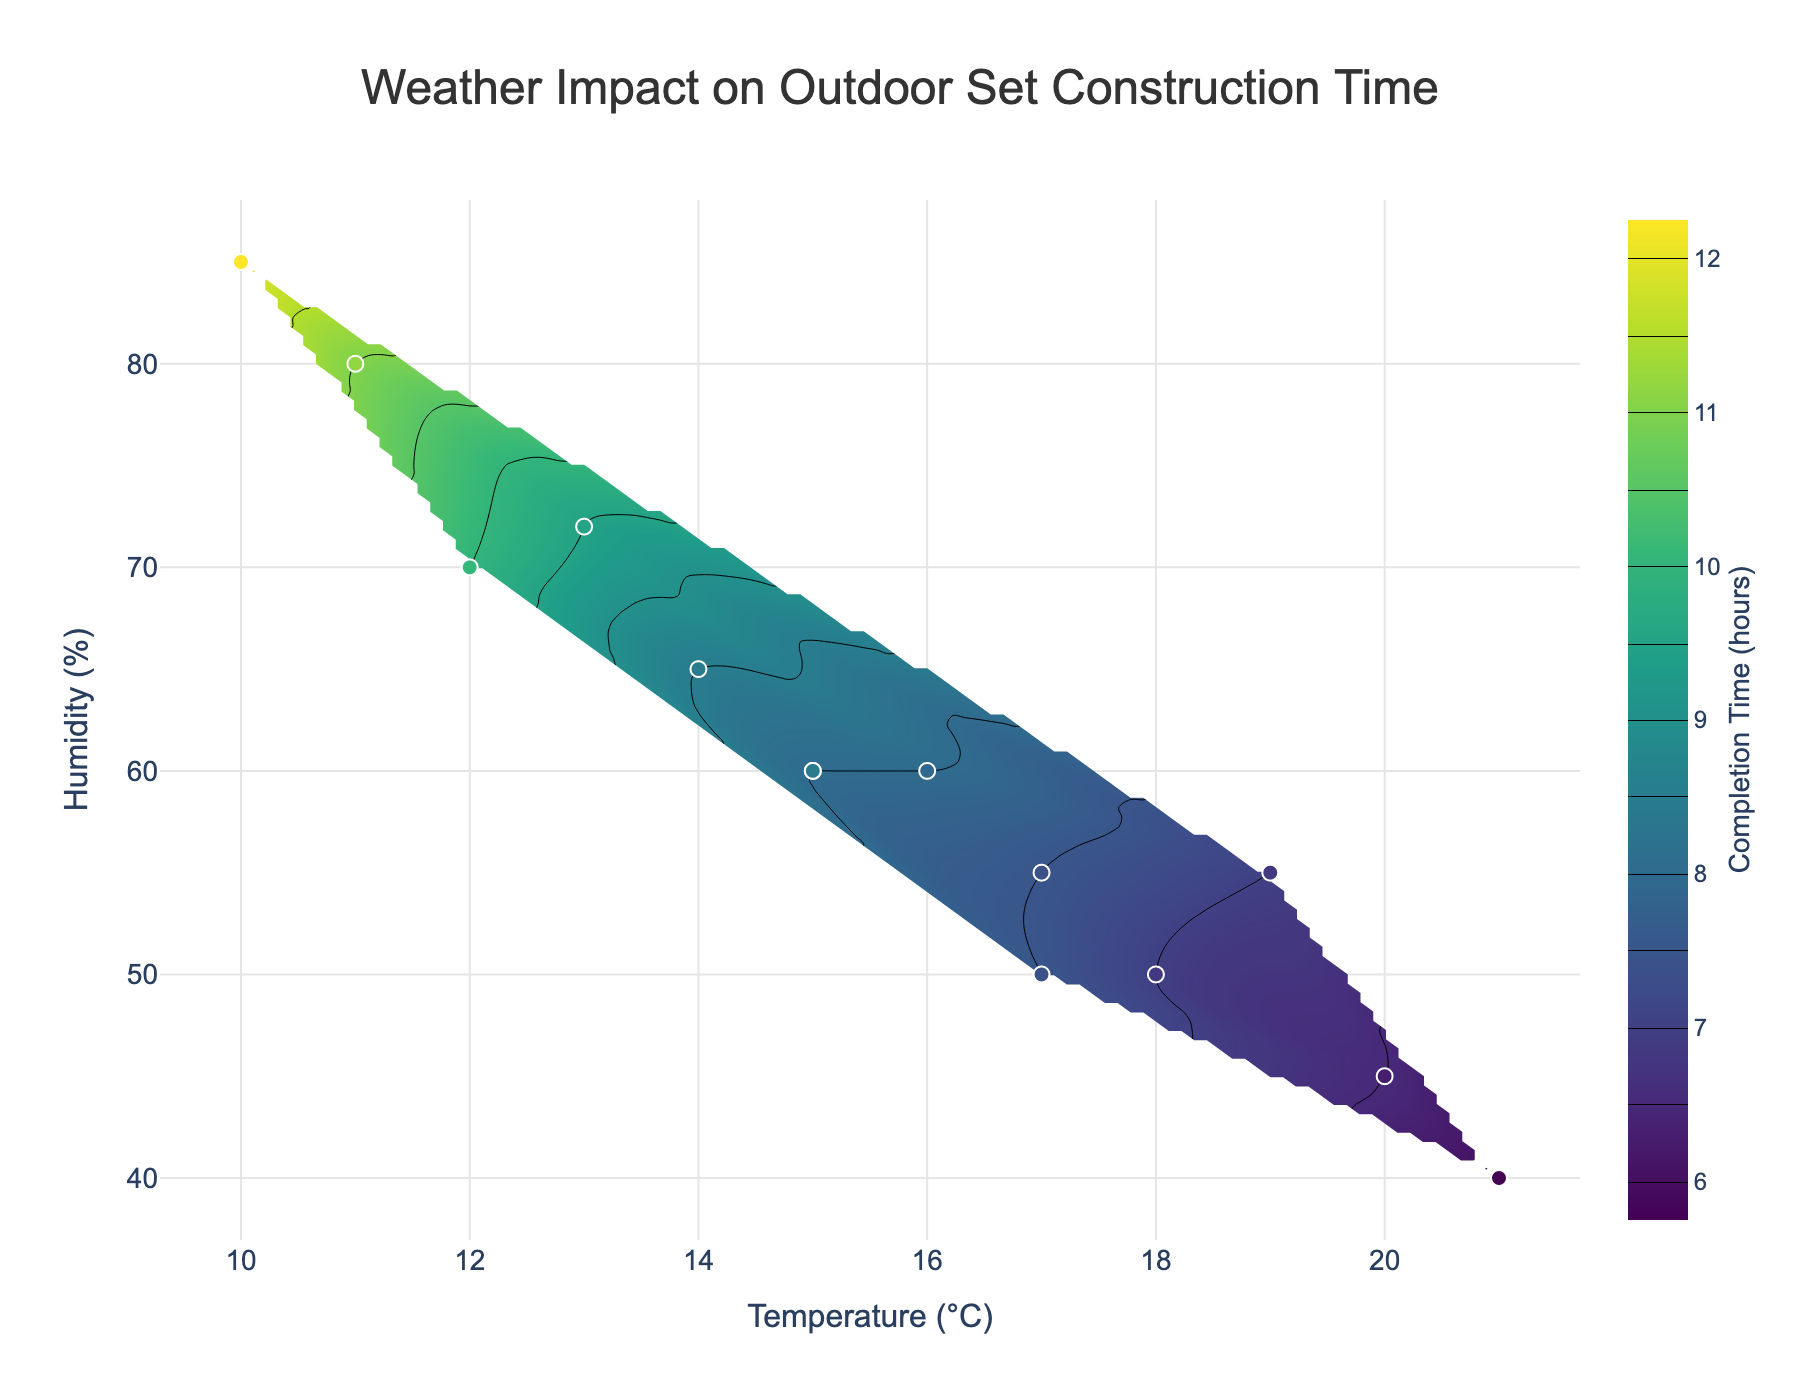What is the title of the contour plot? Look at the top of the plot where the title is displayed.
Answer: Weather Impact on Outdoor Set Construction Time What is the range of the Temperature axis? The Temperature axis ranges from the minimum to the maximum temperature found in the data, as indicated on the x-axis.
Answer: 10°C to 21°C How many actual data points are marked on the plot? Count the number of scatter markers on the plot representing the actual data points.
Answer: 14 Which combination of temperature and humidity has the highest completion time in the plot? Find the region with the darkest color on the contour map, indicating the longest completion time. Refer to the colorbar for exact timing.
Answer: Around 10°C and 85% How does the completion time vary with increasing temperature at constant humidity of 60%? Check the contour lines at the vertical line for humidity = 60%, and observe the trend of completion times as temperature increases.
Answer: It decreases What temperature and humidity values correspond to the minimum completion time observed on the plot? Locate the lightest color region on the contour map, indicating the shortest completion time, and find the corresponding temperature and humidity.
Answer: Around 21°C and 40% Is there a clear pattern of how humidity affects completion times at higher temperatures? Observe the contour lines' density and color changes across higher temperature regions (e.g., above 15°C) and varying humidity levels.
Answer: Higher humidity generally increases completion times at higher temperatures What can be inferred about the impact of wind speed and rainfall on completion times? Refer to the scatter plot informational hover text, which includes wind speed and rainfall details for specific dates, to understand additional weather impacts.
Answer: Higher wind speed and rainfall correlate with longer completion times How does the completion time change with increasing humidity at a constant temperature of 15°C? Examine the contour lines along the horizontal line corresponding to 15°C temperature to see how completion times change as humidity increases.
Answer: It generally increases Which date recorded the highest wind speed, and what was the completion time on that day? Use the hover text on the scatter plot to find the date with the highest wind speed and read the corresponding completion time.
Answer: March 4, 12 hours 